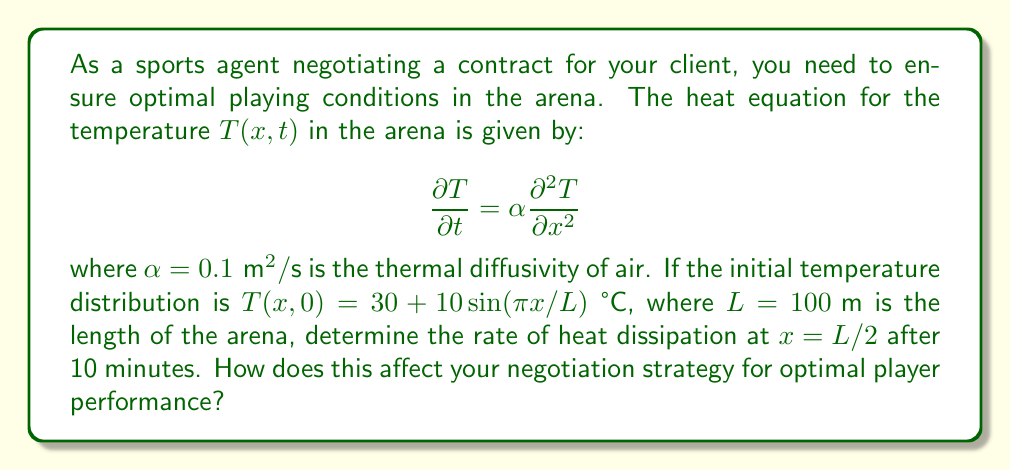Give your solution to this math problem. To solve this problem, we'll follow these steps:

1) The general solution to the heat equation with the given initial condition is:

   $$T(x,t) = 30 + 10e^{-\alpha(\pi/L)^2t}\sin(\pi x/L)$$

2) The rate of heat dissipation is given by the time derivative of temperature:

   $$\frac{\partial T}{\partial t} = -10\alpha(\pi/L)^2e^{-\alpha(\pi/L)^2t}\sin(\pi x/L)$$

3) We need to evaluate this at $x = L/2$ and $t = 600$ s (10 minutes):

   $$\frac{\partial T}{\partial t}\bigg|_{x=L/2,t=600} = -10\alpha(\pi/L)^2e^{-\alpha(\pi/L)^2(600)}\sin(\pi/2)$$

4) Substituting the values:
   $\alpha = 0.1 \text{ m}^2/\text{s}$
   $L = 100 \text{ m}$
   $\sin(\pi/2) = 1$

   $$\frac{\partial T}{\partial t}\bigg|_{x=L/2,t=600} = -10(0.1)(\pi/100)^2e^{-0.1(\pi/100)^2(600)}$$

5) Calculating:

   $$\frac{\partial T}{\partial t}\bigg|_{x=L/2,t=600} \approx -0.00296 \text{ °C/s}$$

This rate of heat dissipation is relatively slow, indicating that the temperature at the center of the arena is decreasing by about 0.00296°C per second after 10 minutes. 

For the negotiation strategy, this slow rate of heat dissipation suggests that the arena maintains a fairly stable temperature, which is generally good for player performance. However, you might want to negotiate for better temperature control systems if the initial temperature (which can reach up to 40°C at some points) is too high for optimal performance.
Answer: $-0.00296 \text{ °C/s}$ 